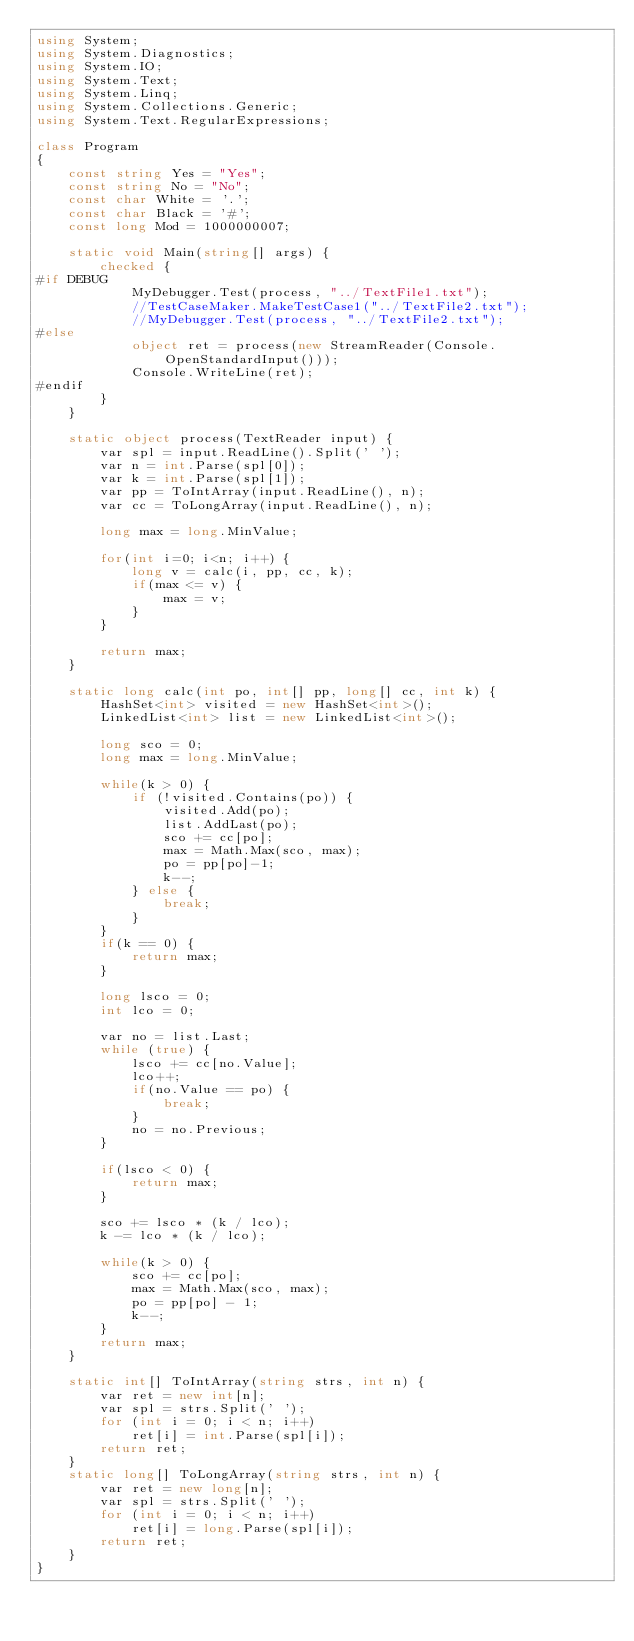Convert code to text. <code><loc_0><loc_0><loc_500><loc_500><_C#_>using System;
using System.Diagnostics;
using System.IO;
using System.Text;
using System.Linq;
using System.Collections.Generic;
using System.Text.RegularExpressions;

class Program
{
    const string Yes = "Yes";
    const string No = "No";
    const char White = '.';
    const char Black = '#';
    const long Mod = 1000000007;

    static void Main(string[] args) {
        checked {
#if DEBUG
            MyDebugger.Test(process, "../TextFile1.txt");
            //TestCaseMaker.MakeTestCase1("../TextFile2.txt");
            //MyDebugger.Test(process, "../TextFile2.txt");
#else
            object ret = process(new StreamReader(Console.OpenStandardInput()));
            Console.WriteLine(ret);
#endif
        }
    }

    static object process(TextReader input) {
        var spl = input.ReadLine().Split(' ');
        var n = int.Parse(spl[0]);
        var k = int.Parse(spl[1]);
        var pp = ToIntArray(input.ReadLine(), n);
        var cc = ToLongArray(input.ReadLine(), n);

        long max = long.MinValue;

        for(int i=0; i<n; i++) {
            long v = calc(i, pp, cc, k);
            if(max <= v) {
                max = v;
            }
        }

        return max;
    }

    static long calc(int po, int[] pp, long[] cc, int k) {
        HashSet<int> visited = new HashSet<int>();
        LinkedList<int> list = new LinkedList<int>();

        long sco = 0;
        long max = long.MinValue;

        while(k > 0) {
            if (!visited.Contains(po)) {
                visited.Add(po);
                list.AddLast(po);
                sco += cc[po];
                max = Math.Max(sco, max);
                po = pp[po]-1;
                k--;
            } else {
                break;
            }
        }
        if(k == 0) {
            return max;
        }

        long lsco = 0;
        int lco = 0;
        
        var no = list.Last;
        while (true) {
            lsco += cc[no.Value];
            lco++;
            if(no.Value == po) {
                break;
            }
            no = no.Previous;
        }

        if(lsco < 0) {
            return max;
        }

        sco += lsco * (k / lco);
        k -= lco * (k / lco);

        while(k > 0) {
            sco += cc[po];
            max = Math.Max(sco, max);
            po = pp[po] - 1;
            k--;
        }
        return max;
    }

    static int[] ToIntArray(string strs, int n) {
        var ret = new int[n];
        var spl = strs.Split(' ');
        for (int i = 0; i < n; i++)
            ret[i] = int.Parse(spl[i]);
        return ret;
    }
    static long[] ToLongArray(string strs, int n) {
        var ret = new long[n];
        var spl = strs.Split(' ');
        for (int i = 0; i < n; i++)
            ret[i] = long.Parse(spl[i]);
        return ret;
    }
}
</code> 